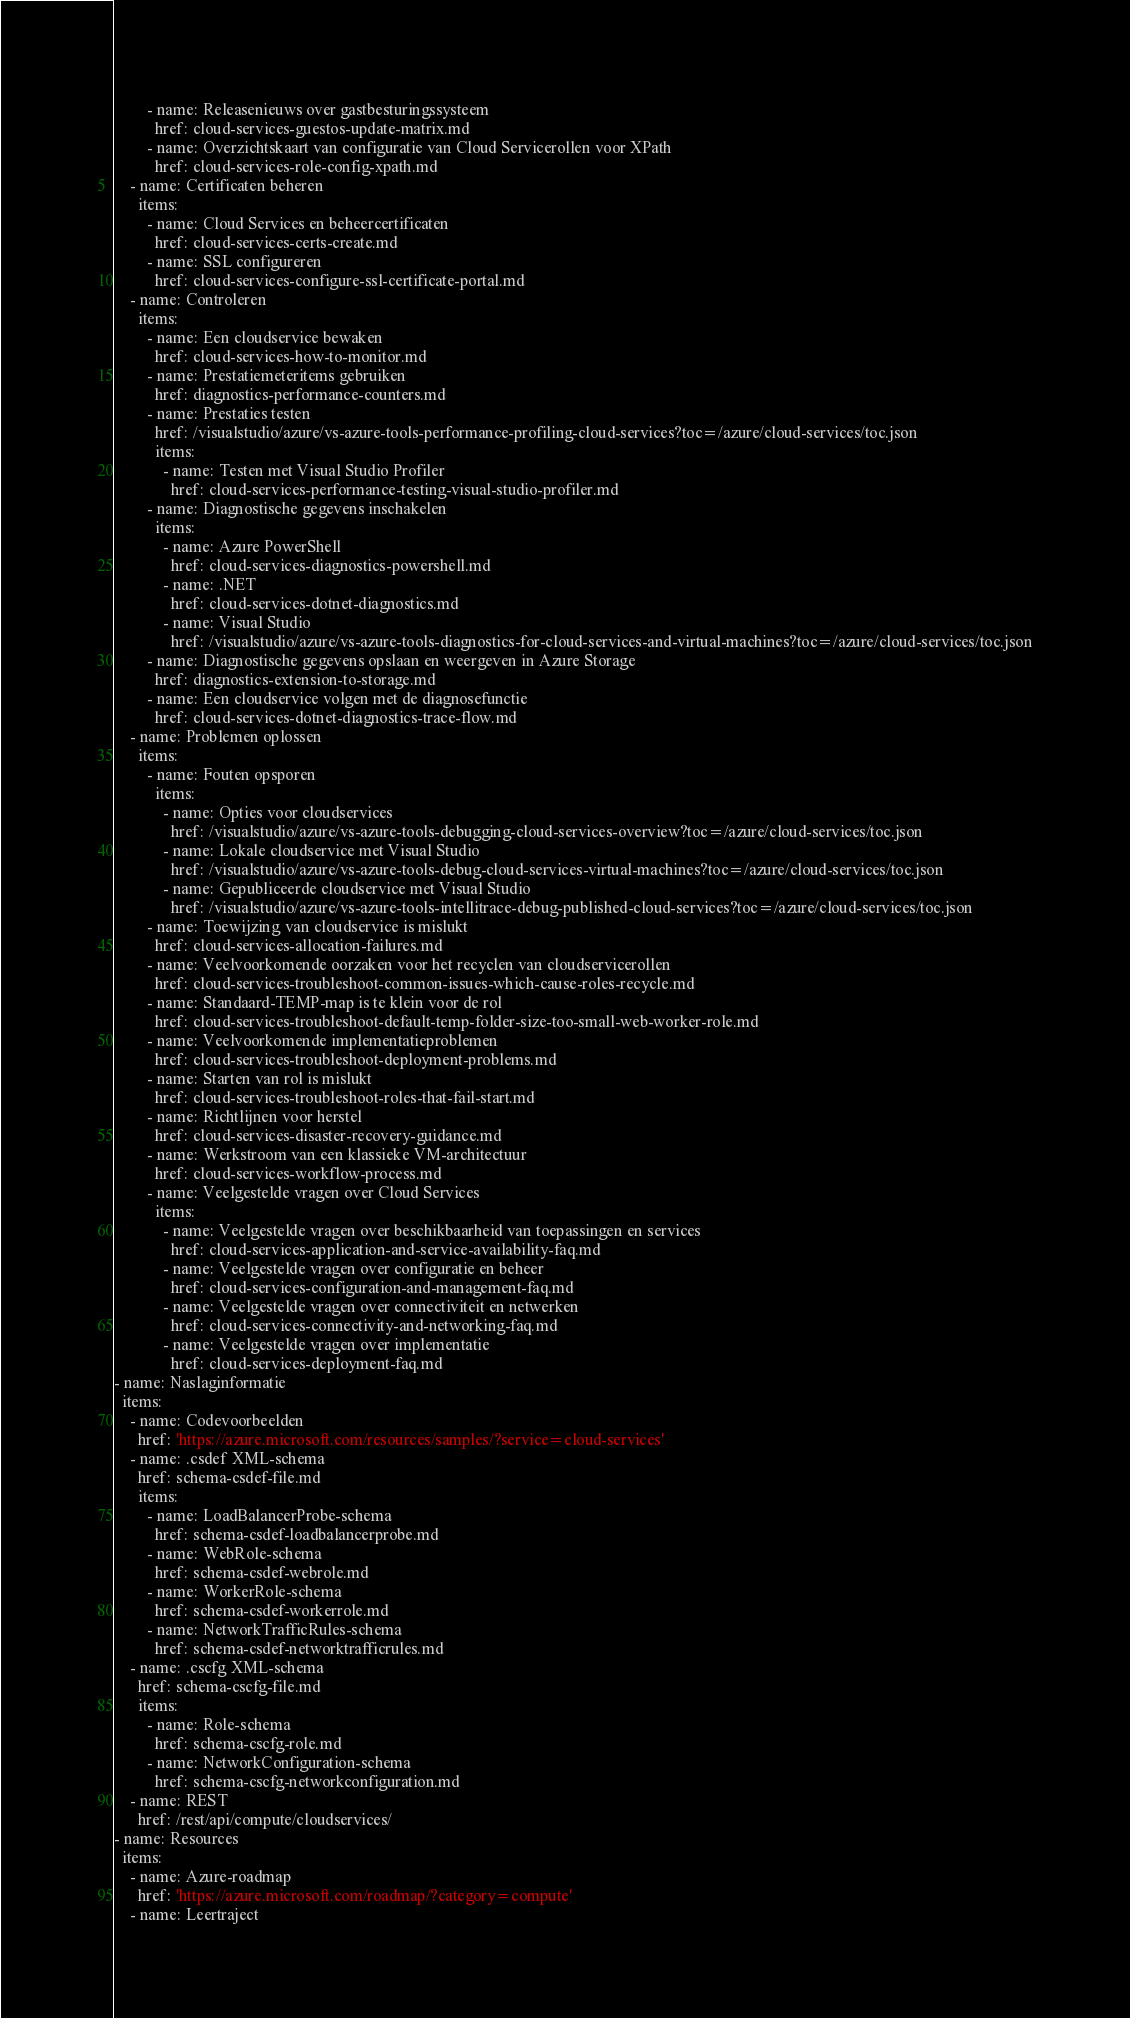Convert code to text. <code><loc_0><loc_0><loc_500><loc_500><_YAML_>        - name: Releasenieuws over gastbesturingssysteem
          href: cloud-services-guestos-update-matrix.md
        - name: Overzichtskaart van configuratie van Cloud Servicerollen voor XPath
          href: cloud-services-role-config-xpath.md
    - name: Certificaten beheren
      items:
        - name: Cloud Services en beheercertificaten
          href: cloud-services-certs-create.md
        - name: SSL configureren
          href: cloud-services-configure-ssl-certificate-portal.md
    - name: Controleren
      items:
        - name: Een cloudservice bewaken
          href: cloud-services-how-to-monitor.md
        - name: Prestatiemeteritems gebruiken
          href: diagnostics-performance-counters.md
        - name: Prestaties testen
          href: /visualstudio/azure/vs-azure-tools-performance-profiling-cloud-services?toc=/azure/cloud-services/toc.json
          items:
            - name: Testen met Visual Studio Profiler
              href: cloud-services-performance-testing-visual-studio-profiler.md
        - name: Diagnostische gegevens inschakelen
          items:
            - name: Azure PowerShell
              href: cloud-services-diagnostics-powershell.md
            - name: .NET
              href: cloud-services-dotnet-diagnostics.md
            - name: Visual Studio
              href: /visualstudio/azure/vs-azure-tools-diagnostics-for-cloud-services-and-virtual-machines?toc=/azure/cloud-services/toc.json
        - name: Diagnostische gegevens opslaan en weergeven in Azure Storage
          href: diagnostics-extension-to-storage.md
        - name: Een cloudservice volgen met de diagnosefunctie
          href: cloud-services-dotnet-diagnostics-trace-flow.md
    - name: Problemen oplossen
      items:
        - name: Fouten opsporen
          items:
            - name: Opties voor cloudservices
              href: /visualstudio/azure/vs-azure-tools-debugging-cloud-services-overview?toc=/azure/cloud-services/toc.json
            - name: Lokale cloudservice met Visual Studio
              href: /visualstudio/azure/vs-azure-tools-debug-cloud-services-virtual-machines?toc=/azure/cloud-services/toc.json
            - name: Gepubliceerde cloudservice met Visual Studio
              href: /visualstudio/azure/vs-azure-tools-intellitrace-debug-published-cloud-services?toc=/azure/cloud-services/toc.json
        - name: Toewijzing van cloudservice is mislukt
          href: cloud-services-allocation-failures.md
        - name: Veelvoorkomende oorzaken voor het recyclen van cloudservicerollen
          href: cloud-services-troubleshoot-common-issues-which-cause-roles-recycle.md
        - name: Standaard-TEMP-map is te klein voor de rol
          href: cloud-services-troubleshoot-default-temp-folder-size-too-small-web-worker-role.md
        - name: Veelvoorkomende implementatieproblemen
          href: cloud-services-troubleshoot-deployment-problems.md
        - name: Starten van rol is mislukt
          href: cloud-services-troubleshoot-roles-that-fail-start.md
        - name: Richtlijnen voor herstel
          href: cloud-services-disaster-recovery-guidance.md
        - name: Werkstroom van een klassieke VM-architectuur
          href: cloud-services-workflow-process.md
        - name: Veelgestelde vragen over Cloud Services
          items:
            - name: Veelgestelde vragen over beschikbaarheid van toepassingen en services
              href: cloud-services-application-and-service-availability-faq.md
            - name: Veelgestelde vragen over configuratie en beheer
              href: cloud-services-configuration-and-management-faq.md
            - name: Veelgestelde vragen over connectiviteit en netwerken
              href: cloud-services-connectivity-and-networking-faq.md
            - name: Veelgestelde vragen over implementatie
              href: cloud-services-deployment-faq.md
- name: Naslaginformatie
  items:
    - name: Codevoorbeelden
      href: 'https://azure.microsoft.com/resources/samples/?service=cloud-services'
    - name: .csdef XML-schema
      href: schema-csdef-file.md
      items:
        - name: LoadBalancerProbe-schema
          href: schema-csdef-loadbalancerprobe.md
        - name: WebRole-schema
          href: schema-csdef-webrole.md
        - name: WorkerRole-schema
          href: schema-csdef-workerrole.md
        - name: NetworkTrafficRules-schema
          href: schema-csdef-networktrafficrules.md
    - name: .cscfg XML-schema
      href: schema-cscfg-file.md
      items:
        - name: Role-schema
          href: schema-cscfg-role.md
        - name: NetworkConfiguration-schema
          href: schema-cscfg-networkconfiguration.md
    - name: REST
      href: /rest/api/compute/cloudservices/
- name: Resources
  items:
    - name: Azure-roadmap
      href: 'https://azure.microsoft.com/roadmap/?category=compute'
    - name: Leertraject</code> 